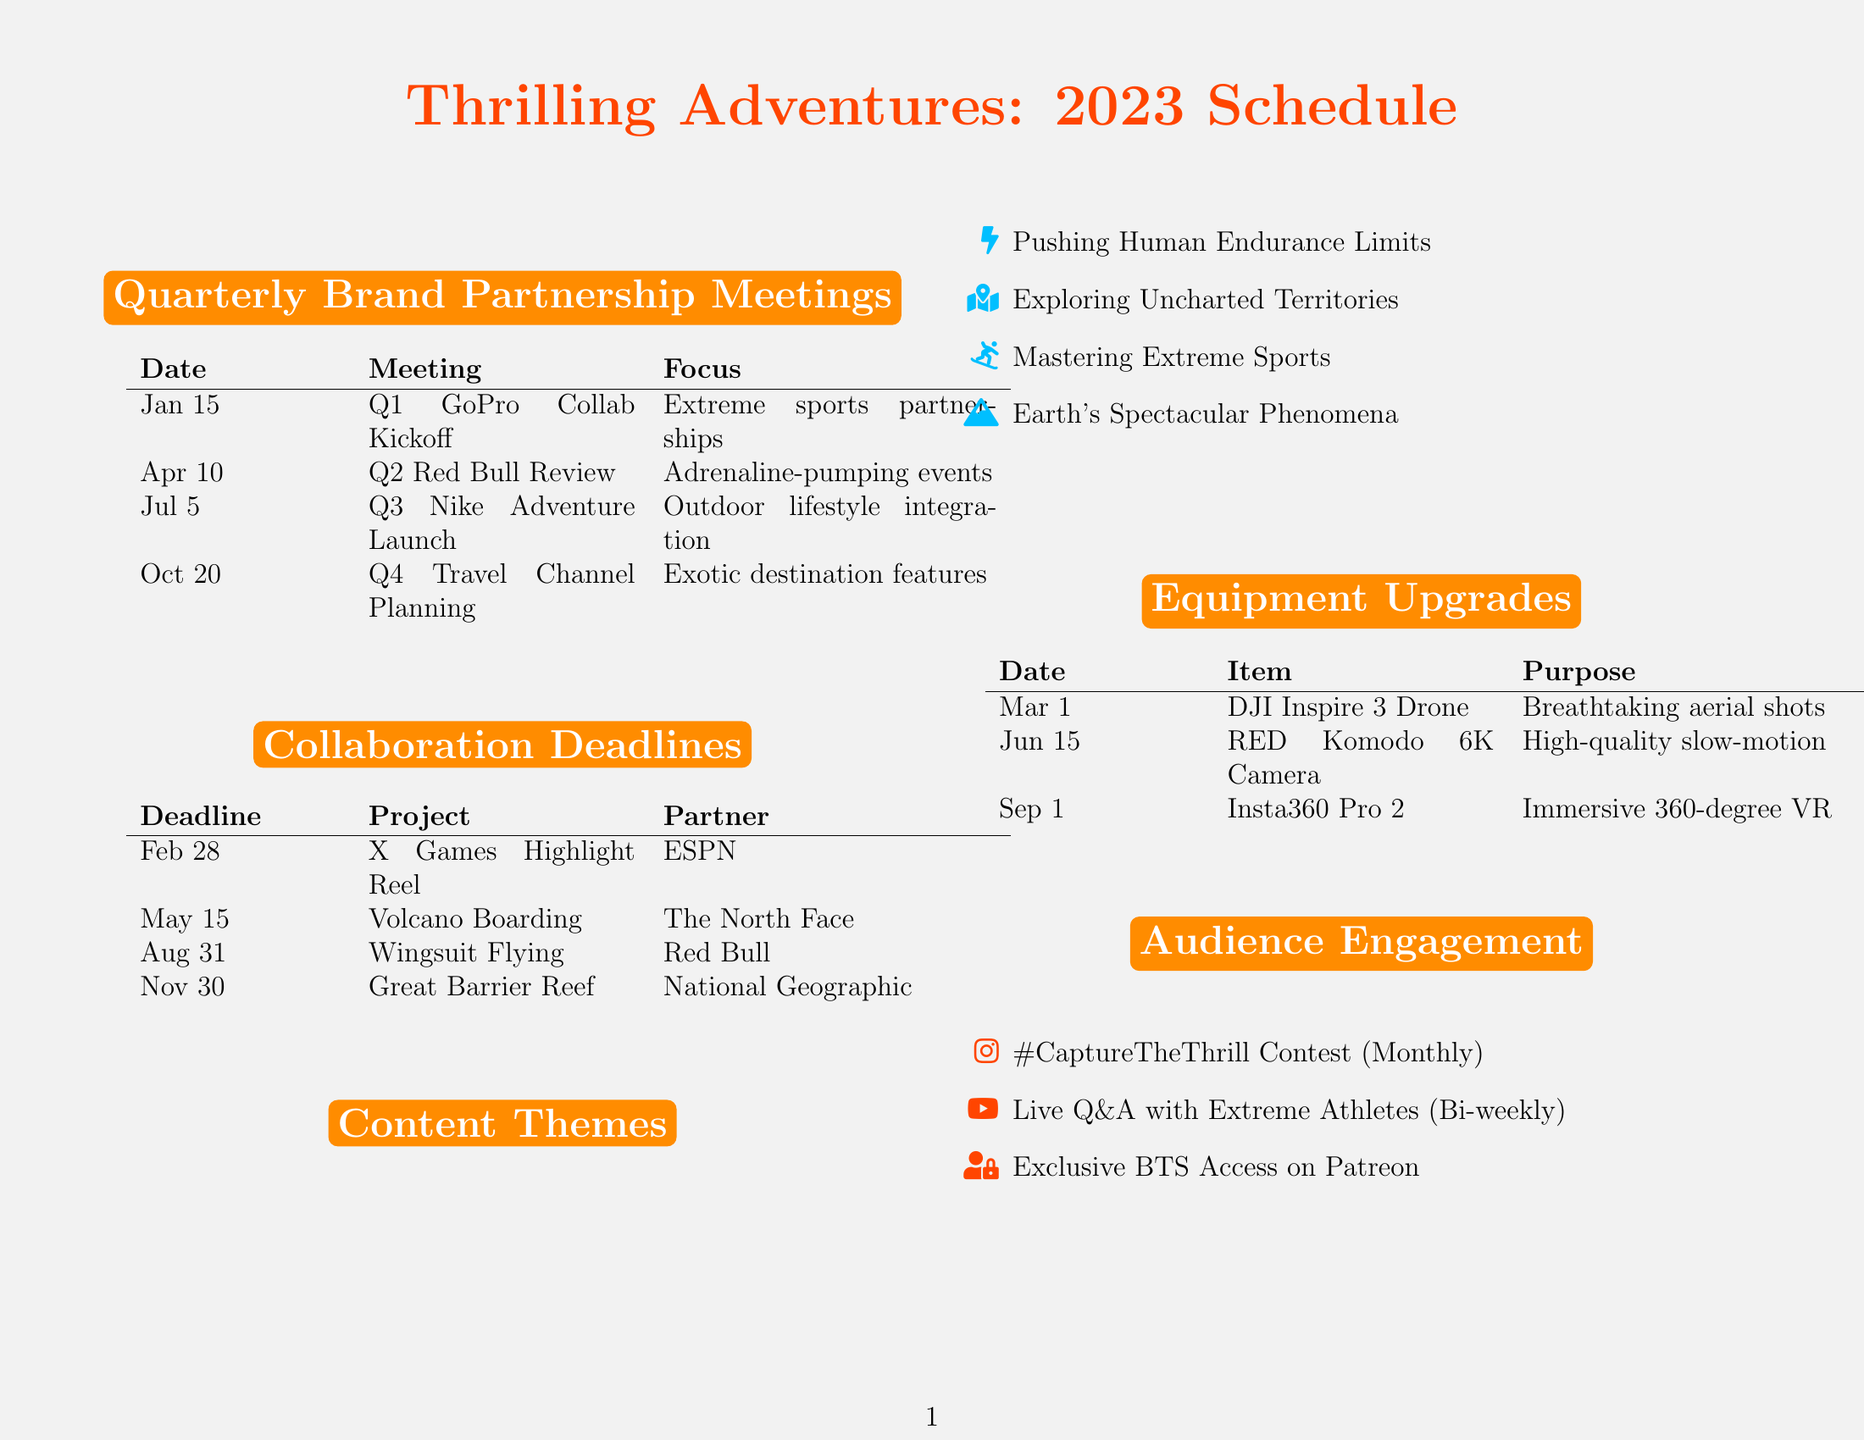What is the date of the Q1 GoPro Collaboration Kickoff meeting? The date for the Q1 GoPro Collaboration Kickoff meeting is specified in the schedule.
Answer: January 15 Who is the key attendee for the Q4 Travel Channel Co-production Planning? The key attendees for the Q4 meeting are listed in the document.
Answer: Travel Channel Executive What is the focus of the Q2 Red Bull Sponsorship Review? The focus of the Q2 meeting is provided in the schedule details.
Answer: Adrenaline-pumping event coverage When is the collaboration deadline for the Wingsuit Flying over the Alps project? The deadline for this project is explicitly mentioned in the collaboration deadlines section.
Answer: August 31 How many deliverables are listed for the X Games Highlight Reel project? The number of deliverables can be counted from the document’s list for this project.
Answer: 3 Which project has a partnership with National Geographic? The document specifies the partner associated with each project, indicating this partnership.
Answer: Great Barrier Reef Underwater Expedition What is one of the content themes mentioned in the document? The content themes are listed in a bulleted format, one of which is the answer.
Answer: Pushing the Limits of Human Endurance What is the purpose of the DJI Inspire 3 Drone? The purpose of each equipment upgrade is detailed, including this drone.
Answer: Aerial cinematography for breathtaking landscape shots What is the frequency of the Live Q&A with Extreme Athletes initiative? The document states the frequency of the audience engagement initiatives.
Answer: Bi-weekly 